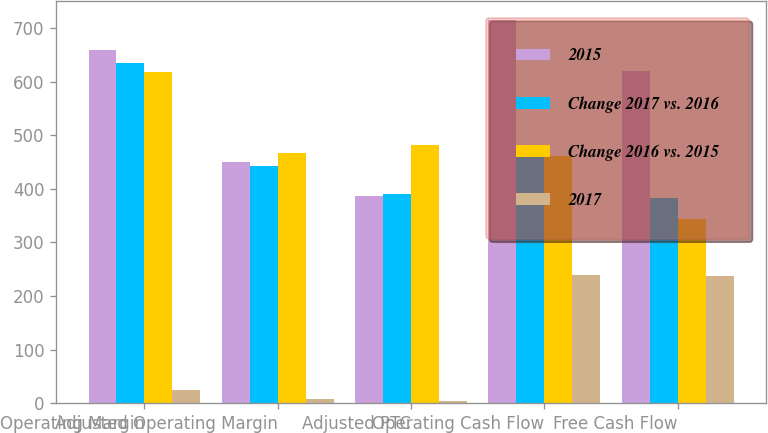Convert chart to OTSL. <chart><loc_0><loc_0><loc_500><loc_500><stacked_bar_chart><ecel><fcel>Operating Margin<fcel>Adjusted Operating Margin<fcel>Adjusted PTC<fcel>Operating Cash Flow<fcel>Free Cash Flow<nl><fcel>2015<fcel>658<fcel>450<fcel>386<fcel>714<fcel>620<nl><fcel>Change 2017 vs. 2016<fcel>634<fcel>442<fcel>390<fcel>475<fcel>383<nl><fcel>Change 2016 vs. 2015<fcel>618<fcel>466<fcel>482<fcel>462<fcel>343<nl><fcel>2017<fcel>24<fcel>8<fcel>4<fcel>239<fcel>237<nl></chart> 